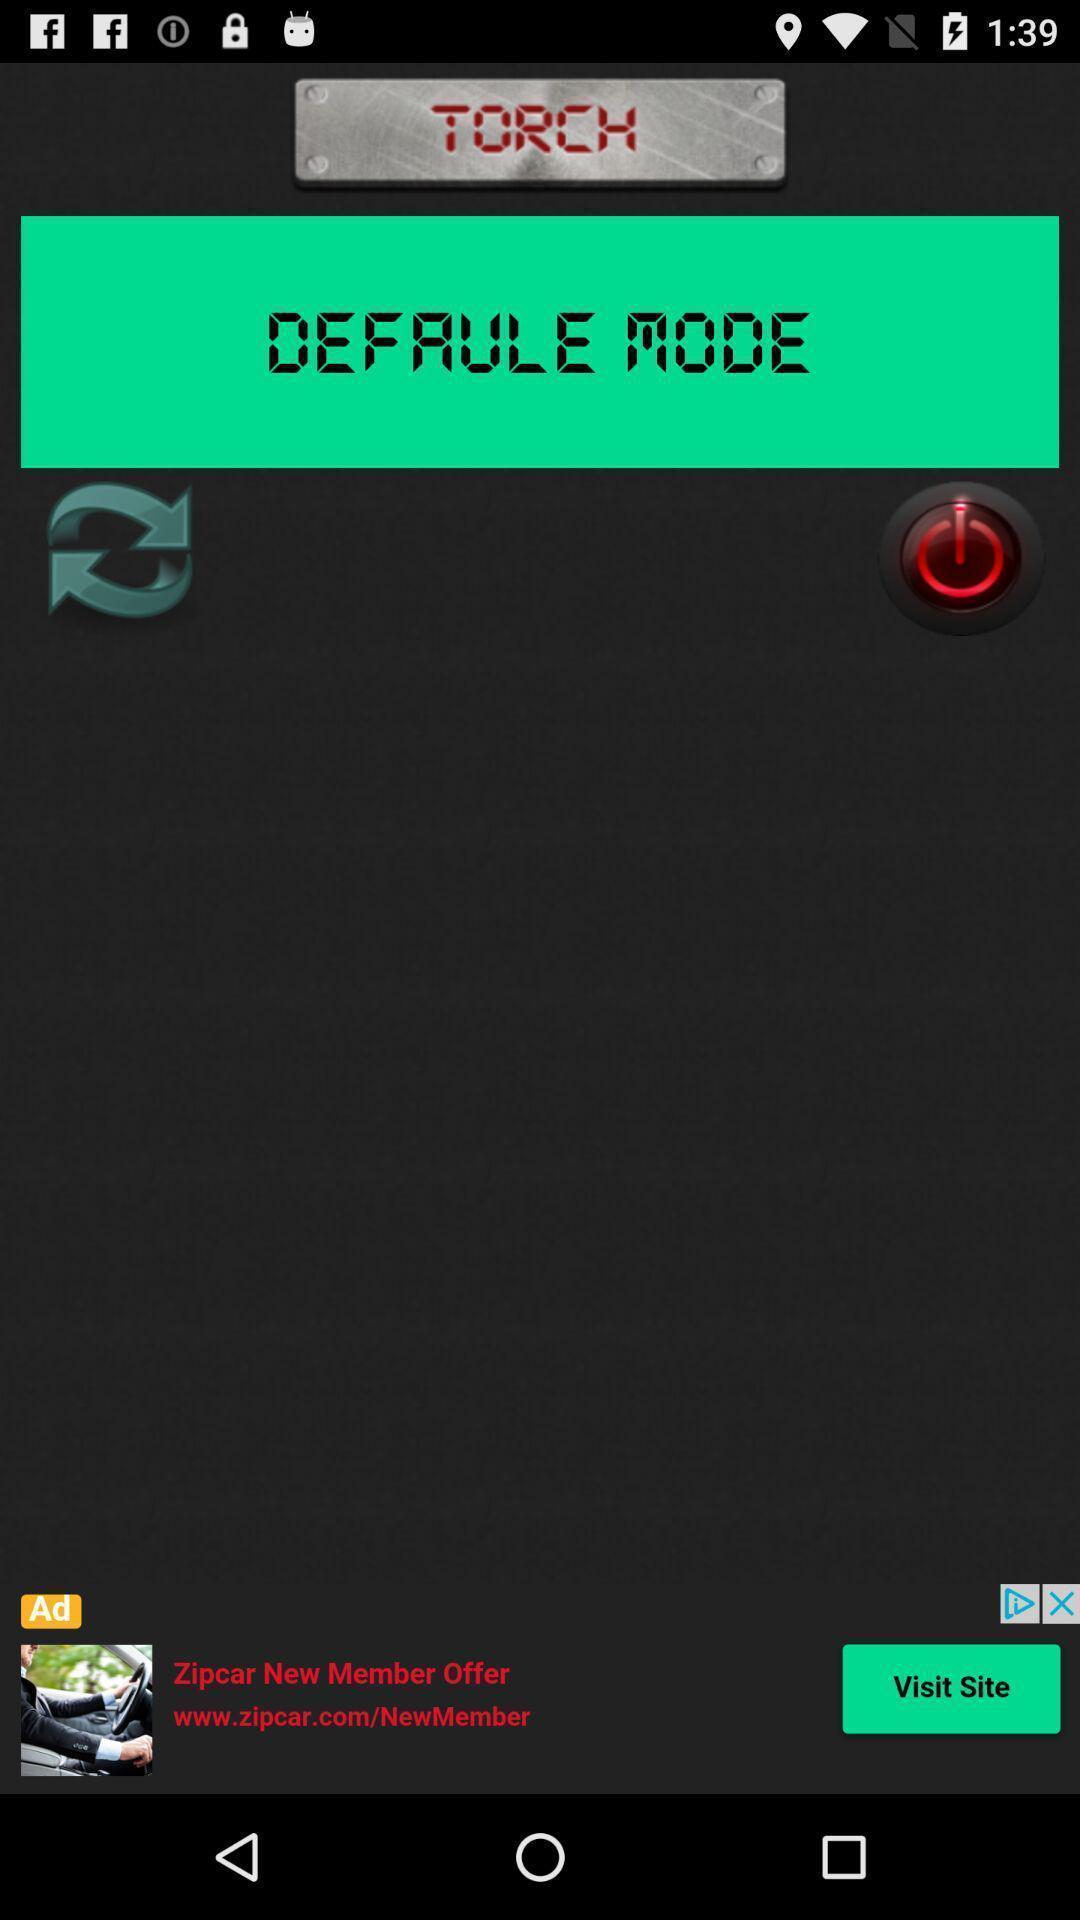Explain what's happening in this screen capture. Page showing information about application. 